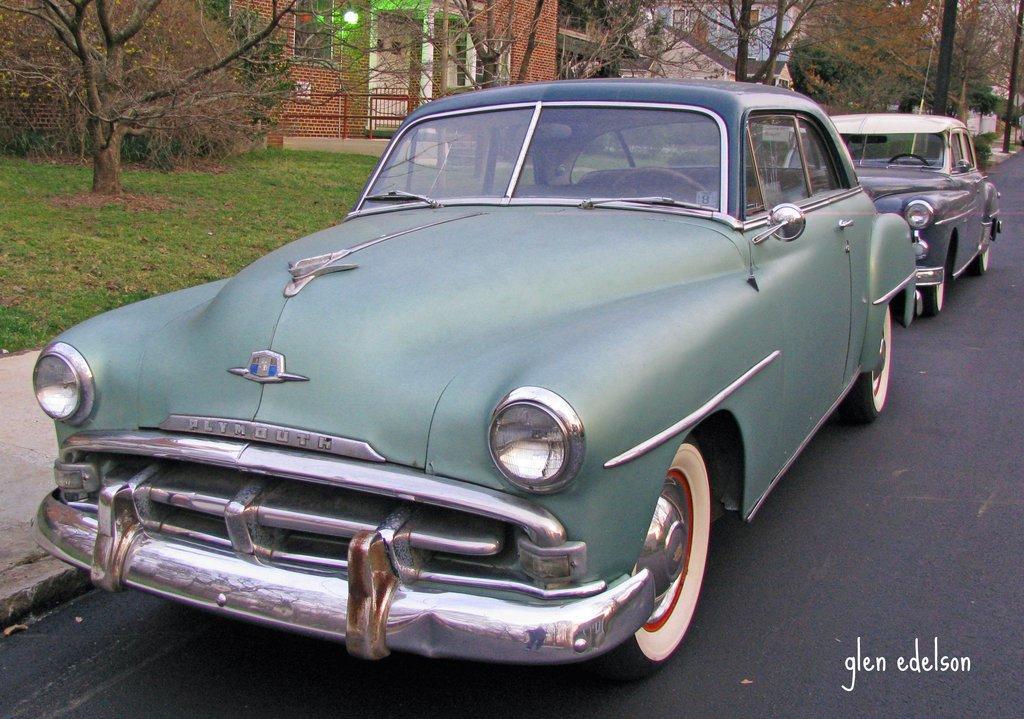Can you describe this image briefly? In this image I can see two cars visible on road in the middle I can see a text at bottom ,at the top I can see trees and building and light and fence 